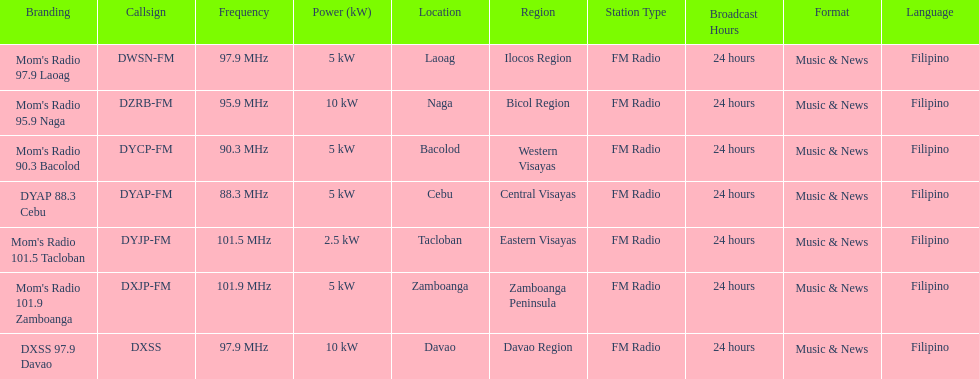What is the radio with the most mhz? Mom's Radio 101.9 Zamboanga. Parse the full table. {'header': ['Branding', 'Callsign', 'Frequency', 'Power (kW)', 'Location', 'Region', 'Station Type', 'Broadcast Hours', 'Format', 'Language'], 'rows': [["Mom's Radio 97.9 Laoag", 'DWSN-FM', '97.9\xa0MHz', '5\xa0kW', 'Laoag', 'Ilocos Region', 'FM Radio', '24 hours', 'Music & News', 'Filipino'], ["Mom's Radio 95.9 Naga", 'DZRB-FM', '95.9\xa0MHz', '10\xa0kW', 'Naga', 'Bicol Region', 'FM Radio', '24 hours', 'Music & News', 'Filipino'], ["Mom's Radio 90.3 Bacolod", 'DYCP-FM', '90.3\xa0MHz', '5\xa0kW', 'Bacolod', 'Western Visayas', 'FM Radio', '24 hours', 'Music & News', 'Filipino'], ['DYAP 88.3 Cebu', 'DYAP-FM', '88.3\xa0MHz', '5\xa0kW', 'Cebu', 'Central Visayas', 'FM Radio', '24 hours', 'Music & News', 'Filipino'], ["Mom's Radio 101.5 Tacloban", 'DYJP-FM', '101.5\xa0MHz', '2.5\xa0kW', 'Tacloban', 'Eastern Visayas', 'FM Radio', '24 hours', 'Music & News', 'Filipino'], ["Mom's Radio 101.9 Zamboanga", 'DXJP-FM', '101.9\xa0MHz', '5\xa0kW', 'Zamboanga', 'Zamboanga Peninsula', 'FM Radio', '24 hours', 'Music & News', 'Filipino'], ['DXSS 97.9 Davao', 'DXSS', '97.9\xa0MHz', '10\xa0kW', 'Davao', 'Davao Region', 'FM Radio', '24 hours', 'Music & News', 'Filipino']]} 